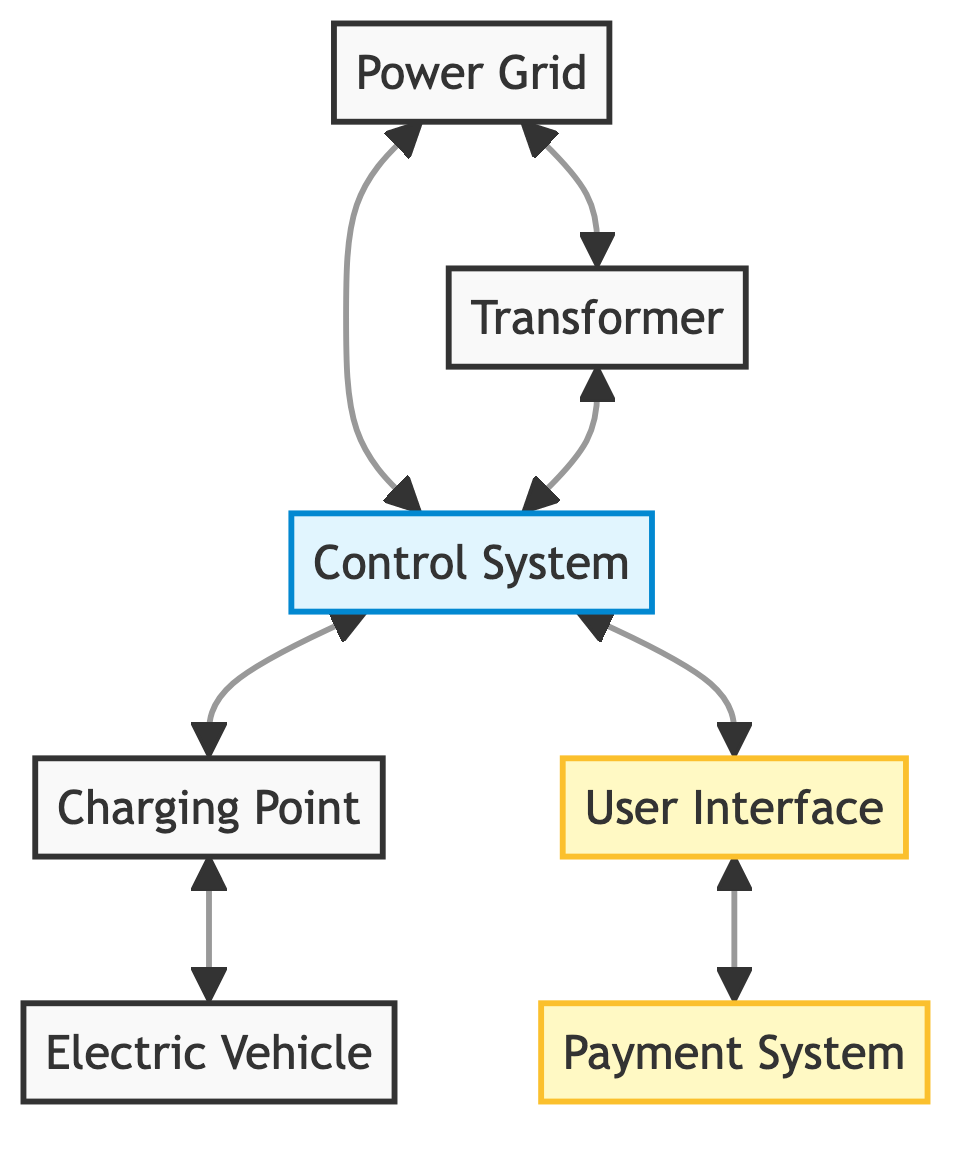What is the role of the Power Grid? The Power Grid is described as the utility power source supplying electricity to the charging station, making it the primary power supply element in the workflow.
Answer: Utility power source How many connections does the Control System have? The Control System connects to four elements: Power Grid, Transformer, Charging Point, and User Interface, making a total of four connections.
Answer: Four What does the User Interface allow users to do? The User Interface is described as allowing users to interact with the charging station, which includes starting/stopping charge sessions and monitoring charge status.
Answer: Interact with charging station Which component steps down high voltage electricity? The Transformer is specifically described as the component that steps down high voltage electricity from the Power Grid to a lower voltage suitable for EV charging.
Answer: Transformer What is the connection between the Charging Point and Electric Vehicle? The Charging Point connects directly to the Electric Vehicle, indicating that the vehicle plugs into the Charging Point for charging.
Answer: Charging Point Which elements are classified as interfaces in this diagram? In the diagram, the User Interface and the Payment System are specifically labeled as interface elements, indicating their role in user interaction and transactions.
Answer: User Interface and Payment System How does the Control System interact with the Payment System? The Control System has a connection to the User Interface, and the User Interface connects to the Payment System, indicating that the interaction occurs through the User Interface.
Answer: Through User Interface What is the main function of the Payment System? The Payment System is described as handling the financial transactions for the charging services provided, indicating its primary function.
Answer: Financial transactions What are the two nodes connected to the Transformer? The Transformer is connected to the Power Grid and the Control System, indicating its role as an intermediary between these two components.
Answer: Power Grid and Control System 